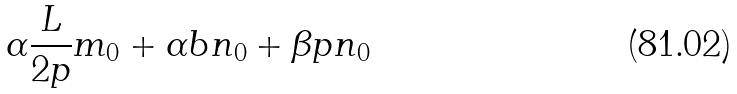Convert formula to latex. <formula><loc_0><loc_0><loc_500><loc_500>\alpha \frac { L } { 2 p } m _ { 0 } + \alpha b n _ { 0 } + \beta p n _ { 0 }</formula> 